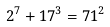Convert formula to latex. <formula><loc_0><loc_0><loc_500><loc_500>2 ^ { 7 } + 1 7 ^ { 3 } = 7 1 ^ { 2 }</formula> 